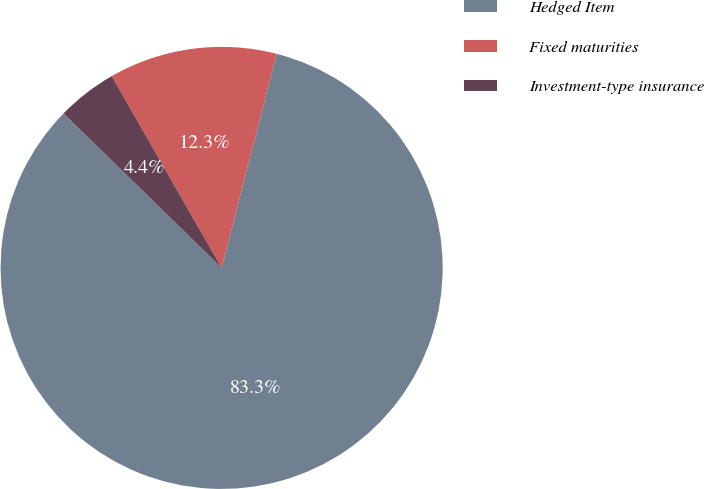<chart> <loc_0><loc_0><loc_500><loc_500><pie_chart><fcel>Hedged Item<fcel>Fixed maturities<fcel>Investment-type insurance<nl><fcel>83.3%<fcel>12.29%<fcel>4.4%<nl></chart> 